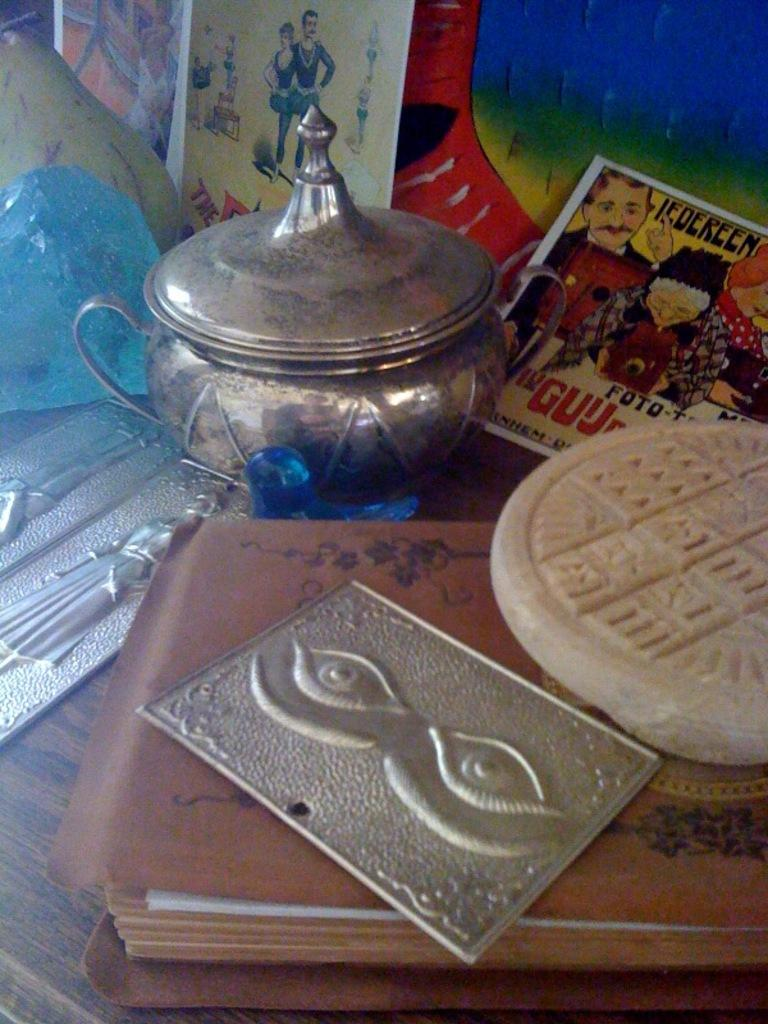What type of object is the water vessel in the image? There is a water vessel in the image. What other items can be seen on the table in the image? There is a book and cards in the image, along with other objects. How does the paper unit affect the throat in the image? There is no paper unit or mention of a throat in the image. 